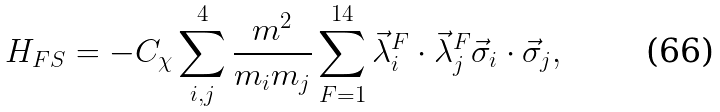Convert formula to latex. <formula><loc_0><loc_0><loc_500><loc_500>H _ { F S } = - C _ { \chi } \sum _ { i , j } ^ { 4 } \frac { m ^ { 2 } } { m _ { i } m _ { j } } \sum _ { F = 1 } ^ { 1 4 } \vec { \lambda } _ { i } ^ { F } \cdot \vec { \lambda } _ { j } ^ { F } \vec { \sigma } _ { i } \cdot \vec { \sigma } _ { j } ,</formula> 